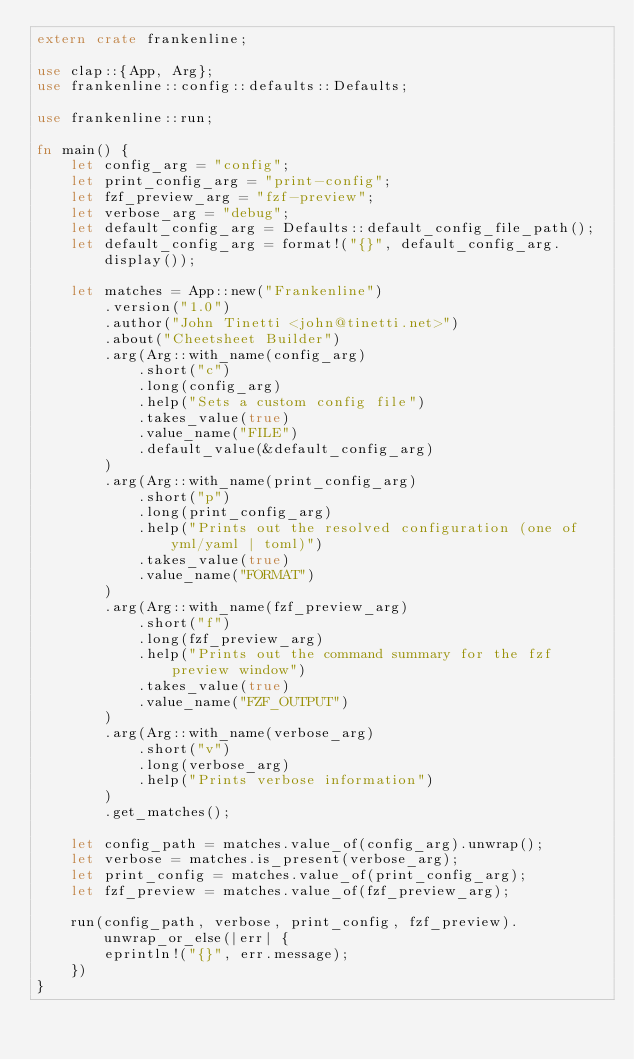Convert code to text. <code><loc_0><loc_0><loc_500><loc_500><_Rust_>extern crate frankenline;

use clap::{App, Arg};
use frankenline::config::defaults::Defaults;

use frankenline::run;

fn main() {
    let config_arg = "config";
    let print_config_arg = "print-config";
    let fzf_preview_arg = "fzf-preview";
    let verbose_arg = "debug";
    let default_config_arg = Defaults::default_config_file_path();
    let default_config_arg = format!("{}", default_config_arg.display());

    let matches = App::new("Frankenline")
        .version("1.0")
        .author("John Tinetti <john@tinetti.net>")
        .about("Cheetsheet Builder")
        .arg(Arg::with_name(config_arg)
            .short("c")
            .long(config_arg)
            .help("Sets a custom config file")
            .takes_value(true)
            .value_name("FILE")
            .default_value(&default_config_arg)
        )
        .arg(Arg::with_name(print_config_arg)
            .short("p")
            .long(print_config_arg)
            .help("Prints out the resolved configuration (one of yml/yaml | toml)")
            .takes_value(true)
            .value_name("FORMAT")
        )
        .arg(Arg::with_name(fzf_preview_arg)
            .short("f")
            .long(fzf_preview_arg)
            .help("Prints out the command summary for the fzf preview window")
            .takes_value(true)
            .value_name("FZF_OUTPUT")
        )
        .arg(Arg::with_name(verbose_arg)
            .short("v")
            .long(verbose_arg)
            .help("Prints verbose information")
        )
        .get_matches();

    let config_path = matches.value_of(config_arg).unwrap();
    let verbose = matches.is_present(verbose_arg);
    let print_config = matches.value_of(print_config_arg);
    let fzf_preview = matches.value_of(fzf_preview_arg);

    run(config_path, verbose, print_config, fzf_preview).unwrap_or_else(|err| {
        eprintln!("{}", err.message);
    })
}
</code> 